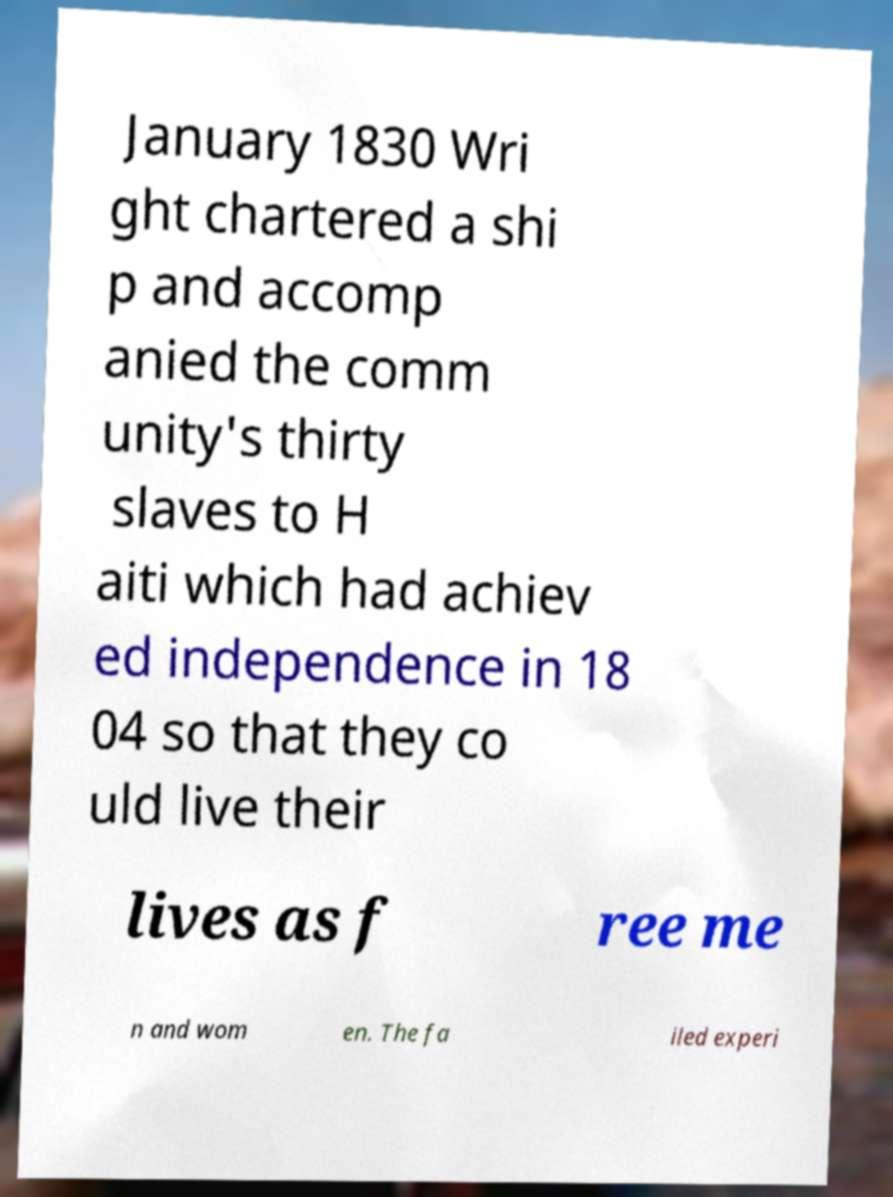Could you assist in decoding the text presented in this image and type it out clearly? January 1830 Wri ght chartered a shi p and accomp anied the comm unity's thirty slaves to H aiti which had achiev ed independence in 18 04 so that they co uld live their lives as f ree me n and wom en. The fa iled experi 